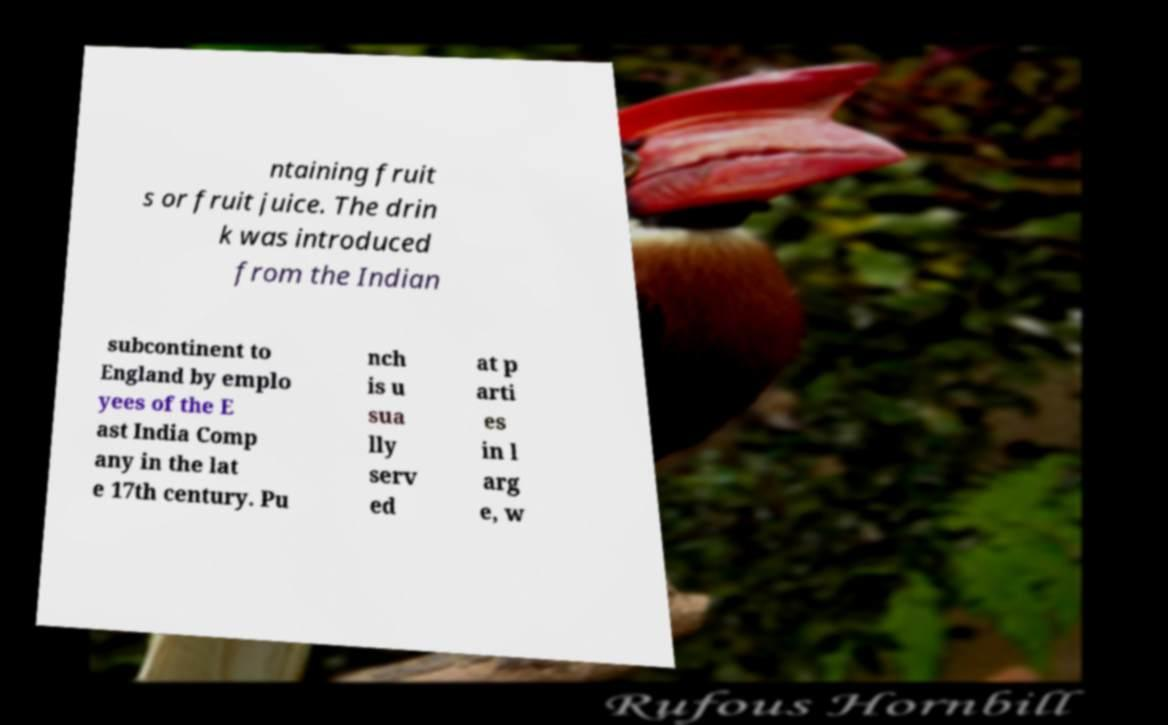There's text embedded in this image that I need extracted. Can you transcribe it verbatim? ntaining fruit s or fruit juice. The drin k was introduced from the Indian subcontinent to England by emplo yees of the E ast India Comp any in the lat e 17th century. Pu nch is u sua lly serv ed at p arti es in l arg e, w 